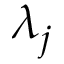<formula> <loc_0><loc_0><loc_500><loc_500>\lambda _ { j }</formula> 